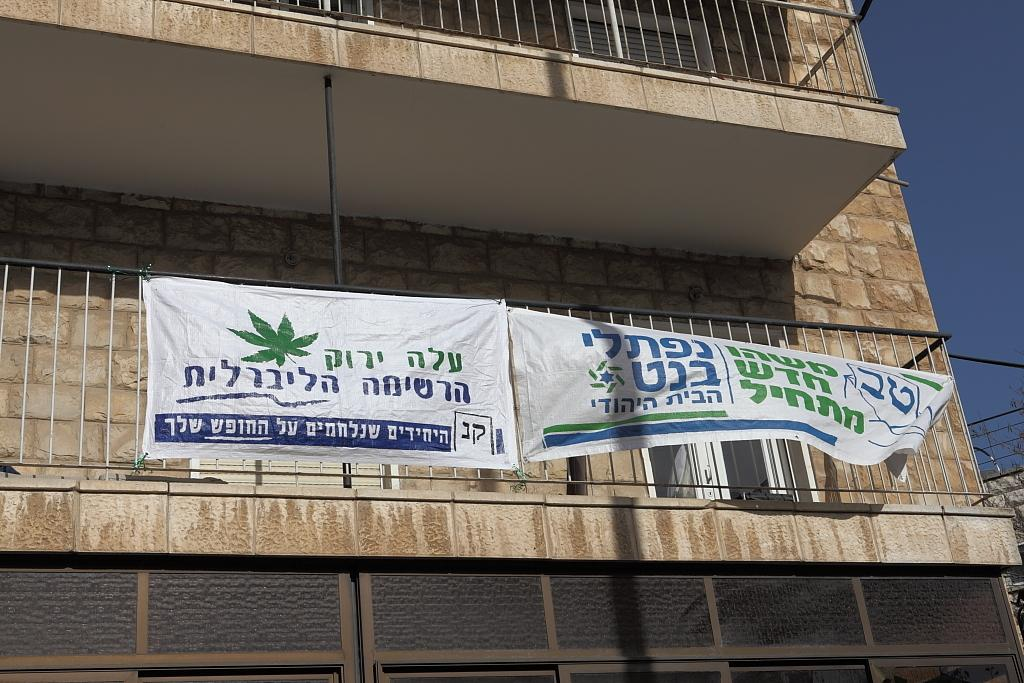What can be seen in the image related to promotional content? There are advertisements in the image. Where are the advertisements located? The advertisements are hanged on the railings of a building. What part of the natural environment is visible in the image? The sky is visible in the image. What type of pet can be seen sitting on the desk in the image? There is no desk or pet present in the image; it only features advertisements hung on the railings of a building and the visible sky. 